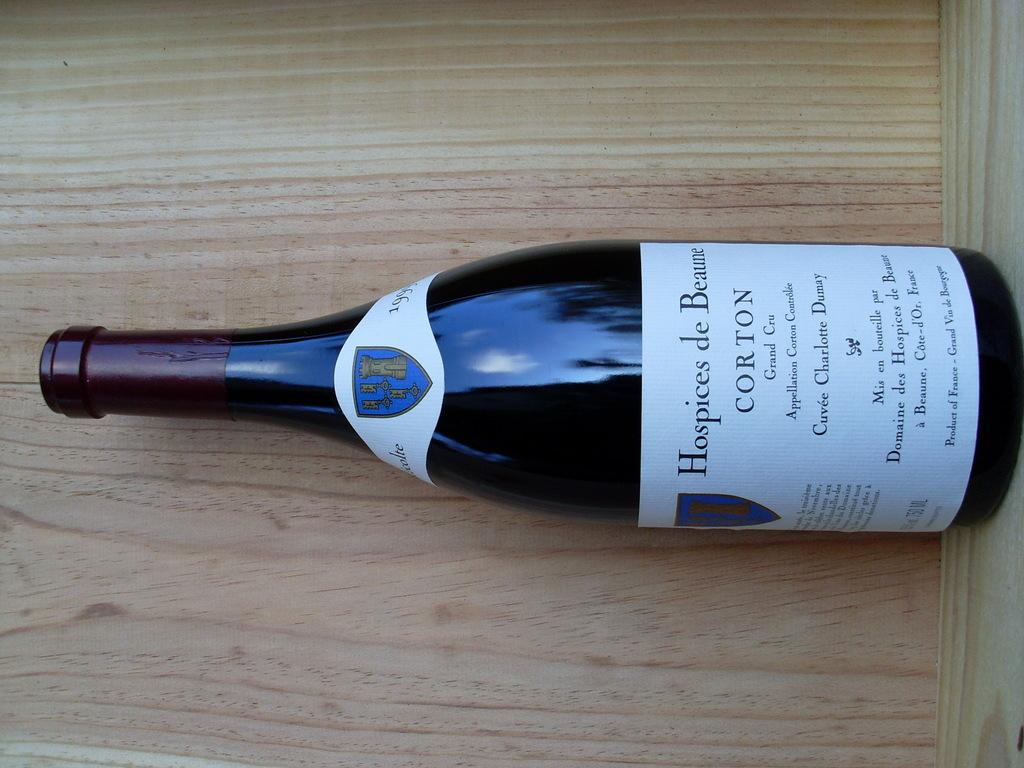<image>
Render a clear and concise summary of the photo. A bottle of wine is dated 1999 and has a crest on the top label. 